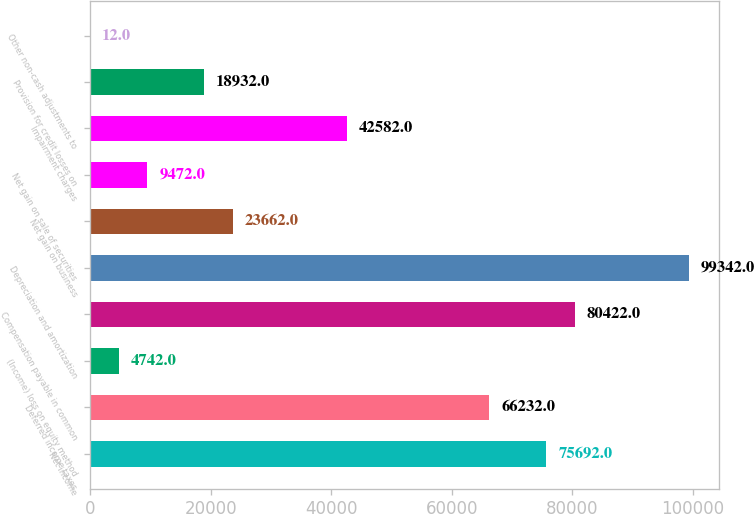<chart> <loc_0><loc_0><loc_500><loc_500><bar_chart><fcel>Net income<fcel>Deferred income taxes<fcel>(Income) loss on equity method<fcel>Compensation payable in common<fcel>Depreciation and amortization<fcel>Net gain on business<fcel>Net gain on sale of securities<fcel>Impairment charges<fcel>Provision for credit losses on<fcel>Other non-cash adjustments to<nl><fcel>75692<fcel>66232<fcel>4742<fcel>80422<fcel>99342<fcel>23662<fcel>9472<fcel>42582<fcel>18932<fcel>12<nl></chart> 